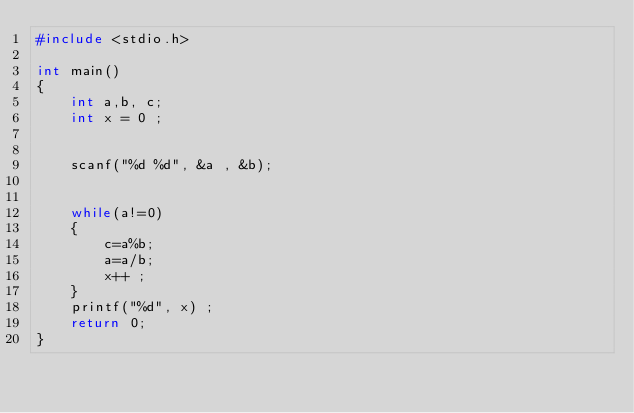<code> <loc_0><loc_0><loc_500><loc_500><_C_>#include <stdio.h>

int main()
{
    int a,b, c;
    int x = 0 ;


    scanf("%d %d", &a , &b);


    while(a!=0)
    {
        c=a%b;
        a=a/b;
        x++ ;
    }
    printf("%d", x) ;
    return 0;
}</code> 